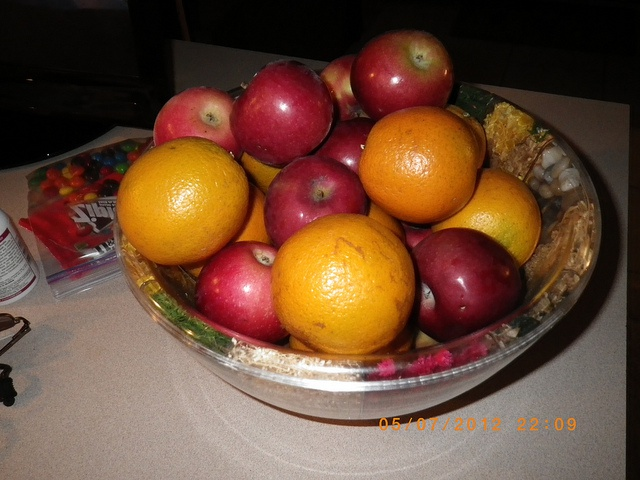Describe the objects in this image and their specific colors. I can see dining table in black, maroon, darkgray, and gray tones, bowl in black, maroon, olive, and gray tones, orange in black, orange, olive, and maroon tones, orange in black, orange, red, and gold tones, and orange in black, orange, brown, and maroon tones in this image. 